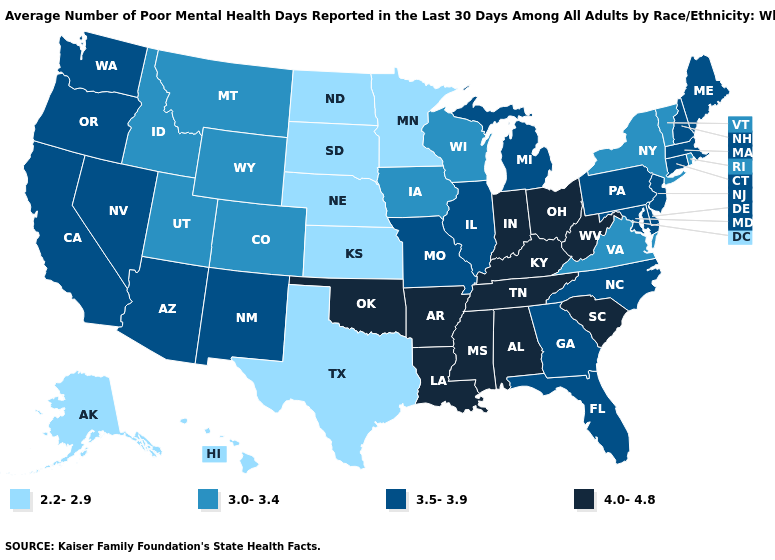What is the lowest value in states that border Texas?
Write a very short answer. 3.5-3.9. Name the states that have a value in the range 4.0-4.8?
Short answer required. Alabama, Arkansas, Indiana, Kentucky, Louisiana, Mississippi, Ohio, Oklahoma, South Carolina, Tennessee, West Virginia. Does Alaska have the lowest value in the West?
Concise answer only. Yes. Does Minnesota have the lowest value in the USA?
Answer briefly. Yes. Does Ohio have the highest value in the USA?
Quick response, please. Yes. What is the lowest value in the Northeast?
Answer briefly. 3.0-3.4. Among the states that border Kentucky , which have the highest value?
Quick response, please. Indiana, Ohio, Tennessee, West Virginia. Name the states that have a value in the range 3.5-3.9?
Keep it brief. Arizona, California, Connecticut, Delaware, Florida, Georgia, Illinois, Maine, Maryland, Massachusetts, Michigan, Missouri, Nevada, New Hampshire, New Jersey, New Mexico, North Carolina, Oregon, Pennsylvania, Washington. What is the value of New Mexico?
Keep it brief. 3.5-3.9. Among the states that border Texas , does Arkansas have the highest value?
Be succinct. Yes. Does Ohio have the highest value in the USA?
Write a very short answer. Yes. What is the value of Vermont?
Short answer required. 3.0-3.4. Which states have the highest value in the USA?
Give a very brief answer. Alabama, Arkansas, Indiana, Kentucky, Louisiana, Mississippi, Ohio, Oklahoma, South Carolina, Tennessee, West Virginia. What is the value of Arkansas?
Concise answer only. 4.0-4.8. Among the states that border Missouri , does Kansas have the lowest value?
Short answer required. Yes. 